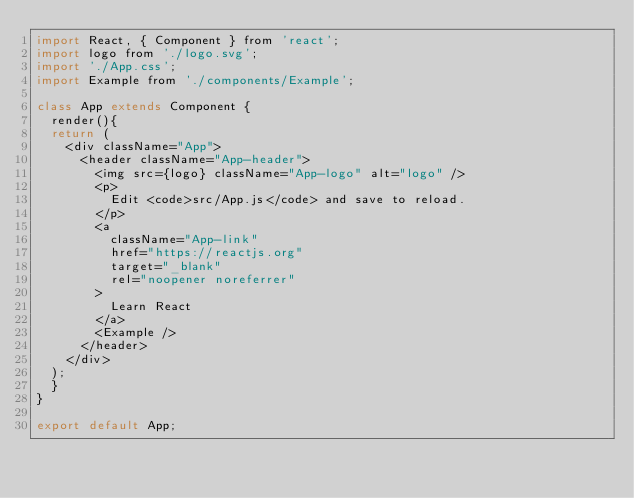<code> <loc_0><loc_0><loc_500><loc_500><_JavaScript_>import React, { Component } from 'react';
import logo from './logo.svg';
import './App.css';
import Example from './components/Example';

class App extends Component {
  render(){
  return (
    <div className="App">
      <header className="App-header">
        <img src={logo} className="App-logo" alt="logo" />
        <p>
          Edit <code>src/App.js</code> and save to reload.
        </p>
        <a
          className="App-link"
          href="https://reactjs.org"
          target="_blank"
          rel="noopener noreferrer"
        >
          Learn React
        </a>
        <Example />
      </header>
    </div>
  );
  }
}

export default App;
</code> 